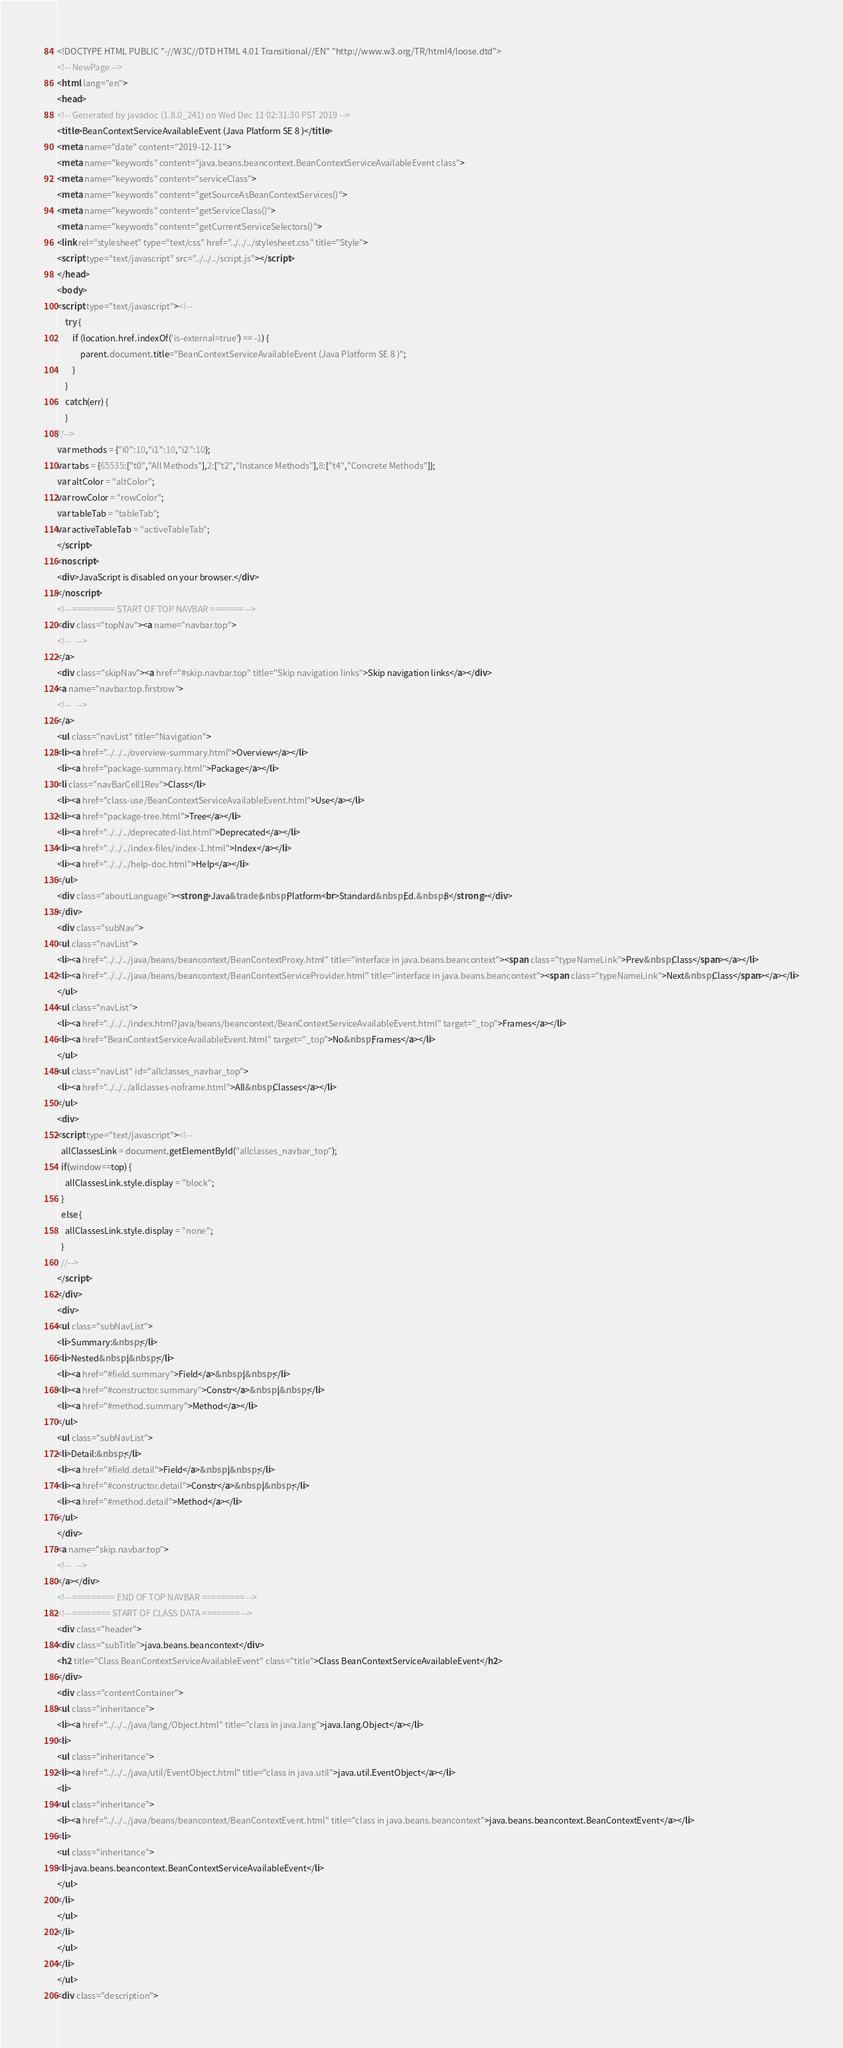<code> <loc_0><loc_0><loc_500><loc_500><_HTML_><!DOCTYPE HTML PUBLIC "-//W3C//DTD HTML 4.01 Transitional//EN" "http://www.w3.org/TR/html4/loose.dtd">
<!-- NewPage -->
<html lang="en">
<head>
<!-- Generated by javadoc (1.8.0_241) on Wed Dec 11 02:31:30 PST 2019 -->
<title>BeanContextServiceAvailableEvent (Java Platform SE 8 )</title>
<meta name="date" content="2019-12-11">
<meta name="keywords" content="java.beans.beancontext.BeanContextServiceAvailableEvent class">
<meta name="keywords" content="serviceClass">
<meta name="keywords" content="getSourceAsBeanContextServices()">
<meta name="keywords" content="getServiceClass()">
<meta name="keywords" content="getCurrentServiceSelectors()">
<link rel="stylesheet" type="text/css" href="../../../stylesheet.css" title="Style">
<script type="text/javascript" src="../../../script.js"></script>
</head>
<body>
<script type="text/javascript"><!--
    try {
        if (location.href.indexOf('is-external=true') == -1) {
            parent.document.title="BeanContextServiceAvailableEvent (Java Platform SE 8 )";
        }
    }
    catch(err) {
    }
//-->
var methods = {"i0":10,"i1":10,"i2":10};
var tabs = {65535:["t0","All Methods"],2:["t2","Instance Methods"],8:["t4","Concrete Methods"]};
var altColor = "altColor";
var rowColor = "rowColor";
var tableTab = "tableTab";
var activeTableTab = "activeTableTab";
</script>
<noscript>
<div>JavaScript is disabled on your browser.</div>
</noscript>
<!-- ========= START OF TOP NAVBAR ======= -->
<div class="topNav"><a name="navbar.top">
<!--   -->
</a>
<div class="skipNav"><a href="#skip.navbar.top" title="Skip navigation links">Skip navigation links</a></div>
<a name="navbar.top.firstrow">
<!--   -->
</a>
<ul class="navList" title="Navigation">
<li><a href="../../../overview-summary.html">Overview</a></li>
<li><a href="package-summary.html">Package</a></li>
<li class="navBarCell1Rev">Class</li>
<li><a href="class-use/BeanContextServiceAvailableEvent.html">Use</a></li>
<li><a href="package-tree.html">Tree</a></li>
<li><a href="../../../deprecated-list.html">Deprecated</a></li>
<li><a href="../../../index-files/index-1.html">Index</a></li>
<li><a href="../../../help-doc.html">Help</a></li>
</ul>
<div class="aboutLanguage"><strong>Java&trade;&nbsp;Platform<br>Standard&nbsp;Ed.&nbsp;8</strong></div>
</div>
<div class="subNav">
<ul class="navList">
<li><a href="../../../java/beans/beancontext/BeanContextProxy.html" title="interface in java.beans.beancontext"><span class="typeNameLink">Prev&nbsp;Class</span></a></li>
<li><a href="../../../java/beans/beancontext/BeanContextServiceProvider.html" title="interface in java.beans.beancontext"><span class="typeNameLink">Next&nbsp;Class</span></a></li>
</ul>
<ul class="navList">
<li><a href="../../../index.html?java/beans/beancontext/BeanContextServiceAvailableEvent.html" target="_top">Frames</a></li>
<li><a href="BeanContextServiceAvailableEvent.html" target="_top">No&nbsp;Frames</a></li>
</ul>
<ul class="navList" id="allclasses_navbar_top">
<li><a href="../../../allclasses-noframe.html">All&nbsp;Classes</a></li>
</ul>
<div>
<script type="text/javascript"><!--
  allClassesLink = document.getElementById("allclasses_navbar_top");
  if(window==top) {
    allClassesLink.style.display = "block";
  }
  else {
    allClassesLink.style.display = "none";
  }
  //-->
</script>
</div>
<div>
<ul class="subNavList">
<li>Summary:&nbsp;</li>
<li>Nested&nbsp;|&nbsp;</li>
<li><a href="#field.summary">Field</a>&nbsp;|&nbsp;</li>
<li><a href="#constructor.summary">Constr</a>&nbsp;|&nbsp;</li>
<li><a href="#method.summary">Method</a></li>
</ul>
<ul class="subNavList">
<li>Detail:&nbsp;</li>
<li><a href="#field.detail">Field</a>&nbsp;|&nbsp;</li>
<li><a href="#constructor.detail">Constr</a>&nbsp;|&nbsp;</li>
<li><a href="#method.detail">Method</a></li>
</ul>
</div>
<a name="skip.navbar.top">
<!--   -->
</a></div>
<!-- ========= END OF TOP NAVBAR ========= -->
<!-- ======== START OF CLASS DATA ======== -->
<div class="header">
<div class="subTitle">java.beans.beancontext</div>
<h2 title="Class BeanContextServiceAvailableEvent" class="title">Class BeanContextServiceAvailableEvent</h2>
</div>
<div class="contentContainer">
<ul class="inheritance">
<li><a href="../../../java/lang/Object.html" title="class in java.lang">java.lang.Object</a></li>
<li>
<ul class="inheritance">
<li><a href="../../../java/util/EventObject.html" title="class in java.util">java.util.EventObject</a></li>
<li>
<ul class="inheritance">
<li><a href="../../../java/beans/beancontext/BeanContextEvent.html" title="class in java.beans.beancontext">java.beans.beancontext.BeanContextEvent</a></li>
<li>
<ul class="inheritance">
<li>java.beans.beancontext.BeanContextServiceAvailableEvent</li>
</ul>
</li>
</ul>
</li>
</ul>
</li>
</ul>
<div class="description"></code> 